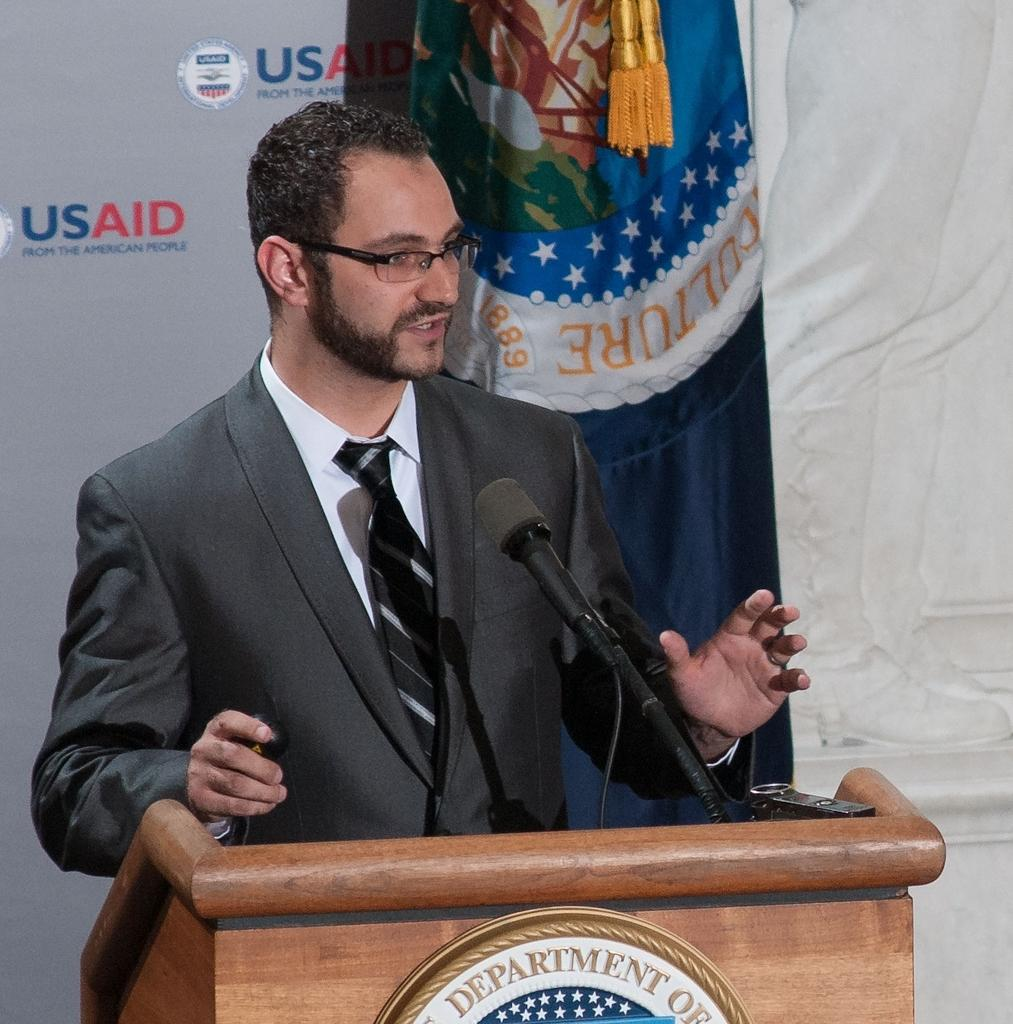What is the main subject of the image? The main subject of the image is a man. What is the man wearing in the image? The man is wearing a blazer, a tie, and spectacles in the image. What is the man standing in front of? The man is standing in front of a mic on a podium. What is visible behind the man? There is a banner, cloth, and carving visible behind the man. Can you tell me how many balloons are floating above the man's head in the image? There are no balloons visible in the image; the focus is on the man, his attire, and the objects around him. 